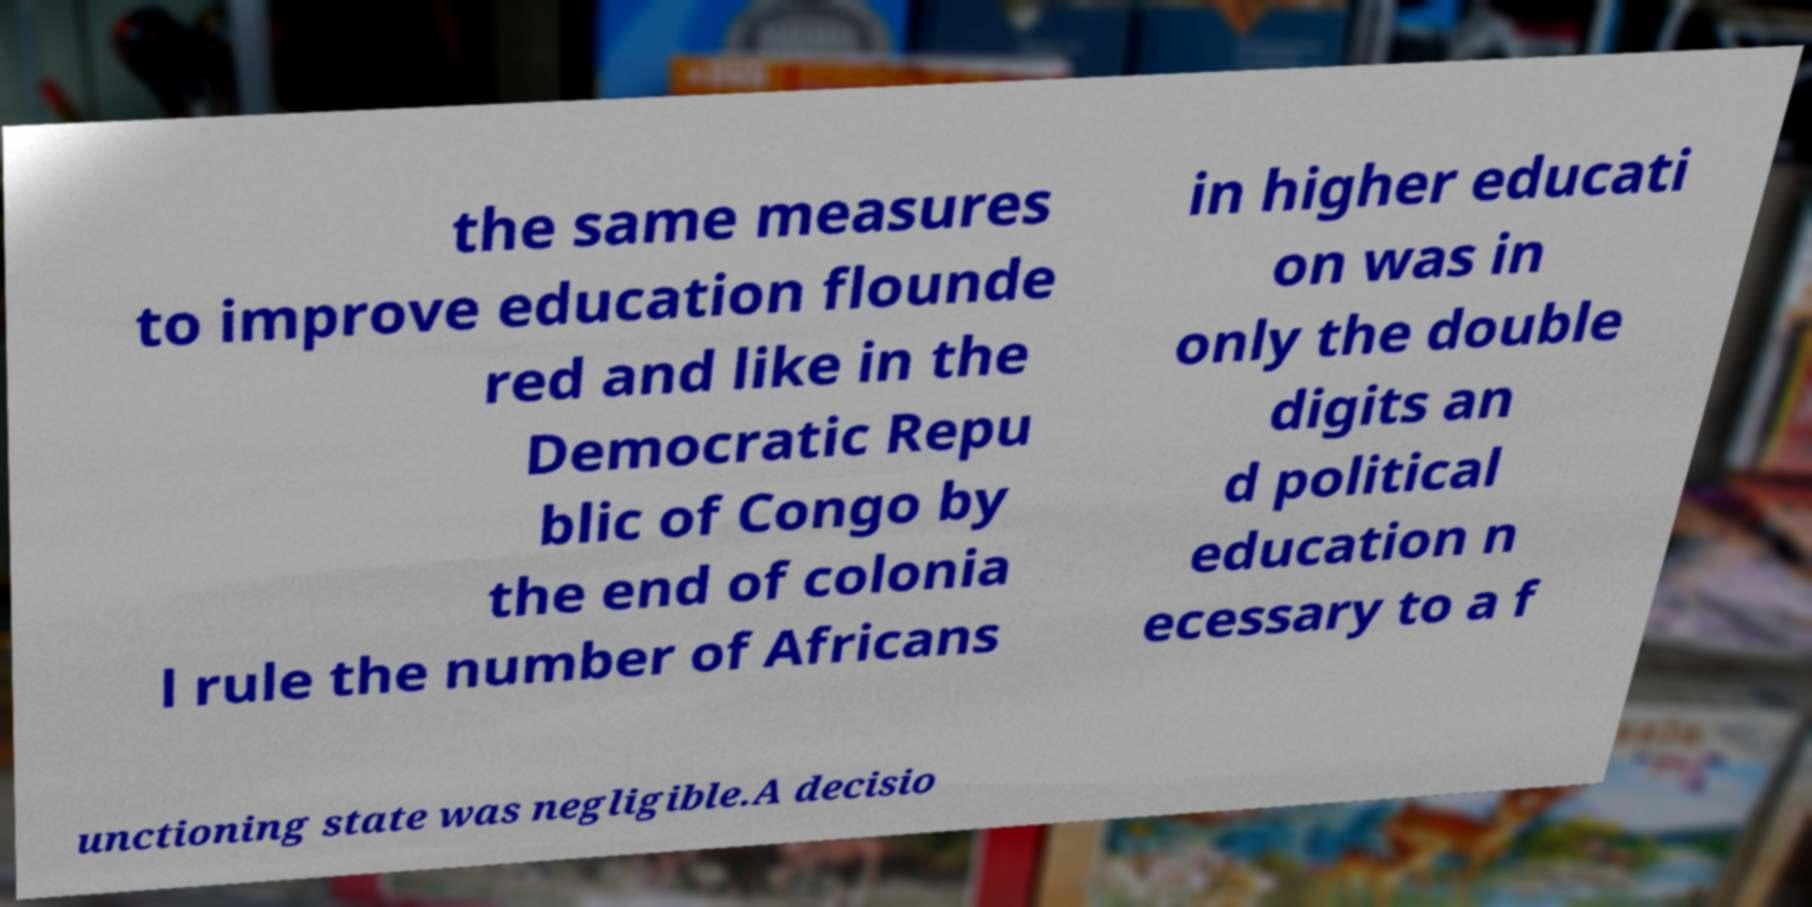Could you extract and type out the text from this image? the same measures to improve education flounde red and like in the Democratic Repu blic of Congo by the end of colonia l rule the number of Africans in higher educati on was in only the double digits an d political education n ecessary to a f unctioning state was negligible.A decisio 